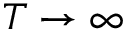Convert formula to latex. <formula><loc_0><loc_0><loc_500><loc_500>T \to \infty</formula> 